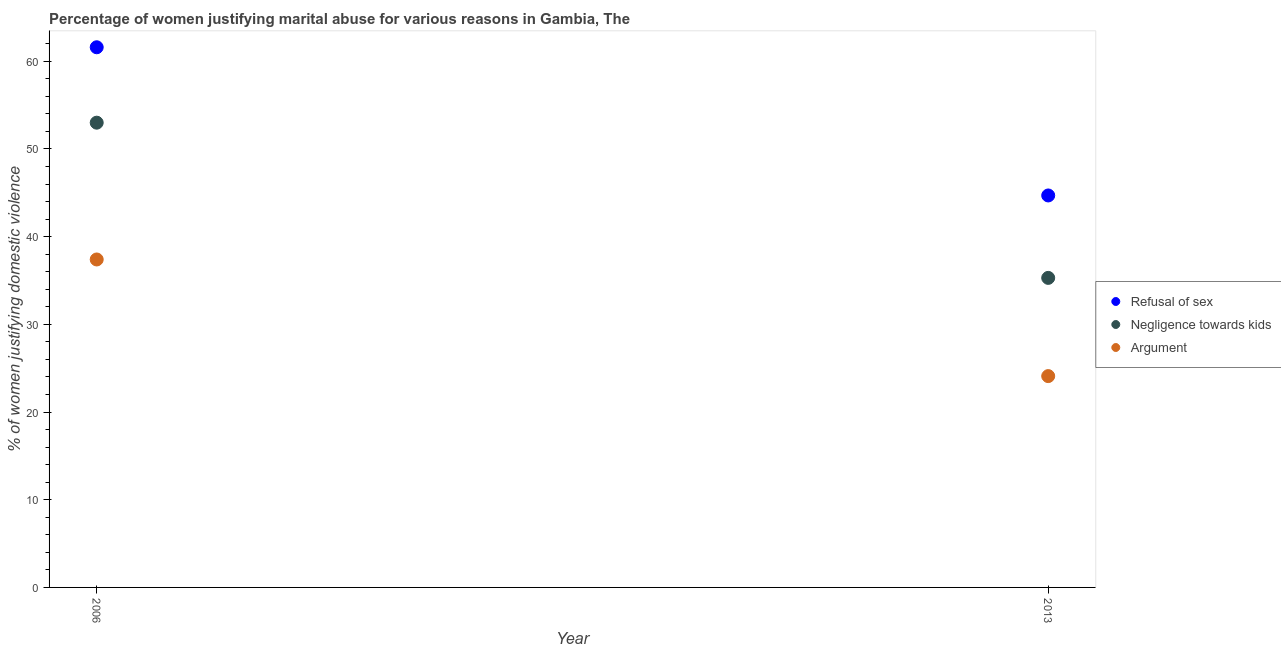What is the percentage of women justifying domestic violence due to negligence towards kids in 2013?
Your response must be concise. 35.3. Across all years, what is the maximum percentage of women justifying domestic violence due to refusal of sex?
Offer a very short reply. 61.6. Across all years, what is the minimum percentage of women justifying domestic violence due to refusal of sex?
Provide a succinct answer. 44.7. In which year was the percentage of women justifying domestic violence due to refusal of sex maximum?
Keep it short and to the point. 2006. In which year was the percentage of women justifying domestic violence due to arguments minimum?
Provide a succinct answer. 2013. What is the total percentage of women justifying domestic violence due to arguments in the graph?
Give a very brief answer. 61.5. What is the difference between the percentage of women justifying domestic violence due to arguments in 2006 and that in 2013?
Keep it short and to the point. 13.3. What is the difference between the percentage of women justifying domestic violence due to negligence towards kids in 2006 and the percentage of women justifying domestic violence due to refusal of sex in 2013?
Your answer should be very brief. 8.3. What is the average percentage of women justifying domestic violence due to arguments per year?
Give a very brief answer. 30.75. In the year 2013, what is the difference between the percentage of women justifying domestic violence due to negligence towards kids and percentage of women justifying domestic violence due to refusal of sex?
Your answer should be compact. -9.4. In how many years, is the percentage of women justifying domestic violence due to negligence towards kids greater than 42 %?
Provide a succinct answer. 1. What is the ratio of the percentage of women justifying domestic violence due to arguments in 2006 to that in 2013?
Your answer should be compact. 1.55. In how many years, is the percentage of women justifying domestic violence due to arguments greater than the average percentage of women justifying domestic violence due to arguments taken over all years?
Ensure brevity in your answer.  1. Is it the case that in every year, the sum of the percentage of women justifying domestic violence due to refusal of sex and percentage of women justifying domestic violence due to negligence towards kids is greater than the percentage of women justifying domestic violence due to arguments?
Ensure brevity in your answer.  Yes. Is the percentage of women justifying domestic violence due to arguments strictly less than the percentage of women justifying domestic violence due to refusal of sex over the years?
Your response must be concise. Yes. How many dotlines are there?
Keep it short and to the point. 3. What is the difference between two consecutive major ticks on the Y-axis?
Keep it short and to the point. 10. Does the graph contain any zero values?
Your answer should be compact. No. Where does the legend appear in the graph?
Your response must be concise. Center right. What is the title of the graph?
Your answer should be very brief. Percentage of women justifying marital abuse for various reasons in Gambia, The. What is the label or title of the Y-axis?
Ensure brevity in your answer.  % of women justifying domestic violence. What is the % of women justifying domestic violence of Refusal of sex in 2006?
Ensure brevity in your answer.  61.6. What is the % of women justifying domestic violence in Argument in 2006?
Offer a very short reply. 37.4. What is the % of women justifying domestic violence in Refusal of sex in 2013?
Make the answer very short. 44.7. What is the % of women justifying domestic violence of Negligence towards kids in 2013?
Keep it short and to the point. 35.3. What is the % of women justifying domestic violence in Argument in 2013?
Your answer should be compact. 24.1. Across all years, what is the maximum % of women justifying domestic violence of Refusal of sex?
Offer a very short reply. 61.6. Across all years, what is the maximum % of women justifying domestic violence of Argument?
Ensure brevity in your answer.  37.4. Across all years, what is the minimum % of women justifying domestic violence of Refusal of sex?
Ensure brevity in your answer.  44.7. Across all years, what is the minimum % of women justifying domestic violence of Negligence towards kids?
Give a very brief answer. 35.3. Across all years, what is the minimum % of women justifying domestic violence of Argument?
Provide a succinct answer. 24.1. What is the total % of women justifying domestic violence of Refusal of sex in the graph?
Give a very brief answer. 106.3. What is the total % of women justifying domestic violence in Negligence towards kids in the graph?
Your answer should be compact. 88.3. What is the total % of women justifying domestic violence in Argument in the graph?
Offer a very short reply. 61.5. What is the difference between the % of women justifying domestic violence of Refusal of sex in 2006 and that in 2013?
Offer a very short reply. 16.9. What is the difference between the % of women justifying domestic violence in Refusal of sex in 2006 and the % of women justifying domestic violence in Negligence towards kids in 2013?
Make the answer very short. 26.3. What is the difference between the % of women justifying domestic violence in Refusal of sex in 2006 and the % of women justifying domestic violence in Argument in 2013?
Keep it short and to the point. 37.5. What is the difference between the % of women justifying domestic violence of Negligence towards kids in 2006 and the % of women justifying domestic violence of Argument in 2013?
Provide a short and direct response. 28.9. What is the average % of women justifying domestic violence of Refusal of sex per year?
Ensure brevity in your answer.  53.15. What is the average % of women justifying domestic violence in Negligence towards kids per year?
Your answer should be very brief. 44.15. What is the average % of women justifying domestic violence in Argument per year?
Offer a terse response. 30.75. In the year 2006, what is the difference between the % of women justifying domestic violence of Refusal of sex and % of women justifying domestic violence of Argument?
Provide a short and direct response. 24.2. In the year 2013, what is the difference between the % of women justifying domestic violence in Refusal of sex and % of women justifying domestic violence in Negligence towards kids?
Keep it short and to the point. 9.4. In the year 2013, what is the difference between the % of women justifying domestic violence in Refusal of sex and % of women justifying domestic violence in Argument?
Your answer should be very brief. 20.6. What is the ratio of the % of women justifying domestic violence of Refusal of sex in 2006 to that in 2013?
Offer a terse response. 1.38. What is the ratio of the % of women justifying domestic violence in Negligence towards kids in 2006 to that in 2013?
Offer a very short reply. 1.5. What is the ratio of the % of women justifying domestic violence in Argument in 2006 to that in 2013?
Offer a terse response. 1.55. What is the difference between the highest and the second highest % of women justifying domestic violence of Negligence towards kids?
Offer a very short reply. 17.7. What is the difference between the highest and the lowest % of women justifying domestic violence of Negligence towards kids?
Your answer should be compact. 17.7. What is the difference between the highest and the lowest % of women justifying domestic violence of Argument?
Offer a terse response. 13.3. 